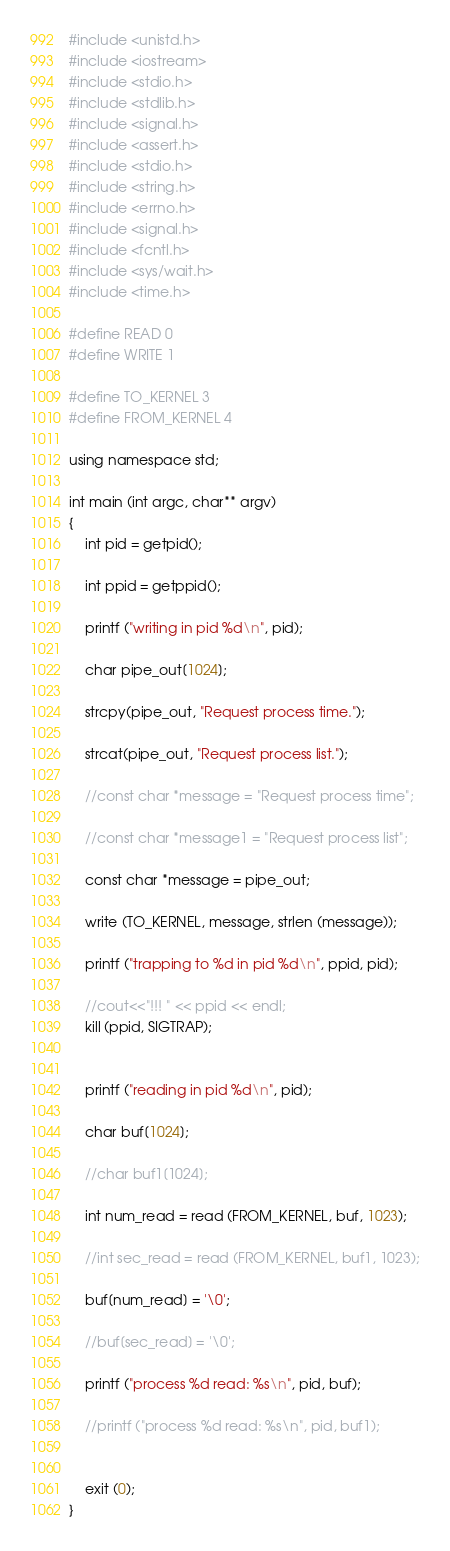Convert code to text. <code><loc_0><loc_0><loc_500><loc_500><_C++_>#include <unistd.h>
#include <iostream>
#include <stdio.h>
#include <stdlib.h>
#include <signal.h>
#include <assert.h>
#include <stdio.h>
#include <string.h>
#include <errno.h>
#include <signal.h>
#include <fcntl.h>
#include <sys/wait.h>
#include <time.h>

#define READ 0
#define WRITE 1

#define TO_KERNEL 3
#define FROM_KERNEL 4

using namespace std;

int main (int argc, char** argv)
{
    int pid = getpid();
    
    int ppid = getppid();

    printf ("writing in pid %d\n", pid);
    
    char pipe_out[1024];
    
    strcpy(pipe_out, "Request process time.");
    
    strcat(pipe_out, "Request process list.");
    
    //const char *message = "Request process time";
    
    //const char *message1 = "Request process list";
    
    const char *message = pipe_out;
    
    write (TO_KERNEL, message, strlen (message));

    printf ("trapping to %d in pid %d\n", ppid, pid);
    
    //cout<<"!!! " << ppid << endl;
    kill (ppid, SIGTRAP);
    

    printf ("reading in pid %d\n", pid);
    
    char buf[1024];
    
    //char buf1[1024];
    
    int num_read = read (FROM_KERNEL, buf, 1023);
    
    //int sec_read = read (FROM_KERNEL, buf1, 1023);
    
    buf[num_read] = '\0';
    
    //buf[sec_read] = '\0';
    
    printf ("process %d read: %s\n", pid, buf);
    
    //printf ("process %d read: %s\n", pid, buf1);
    

    exit (0);
}
</code> 